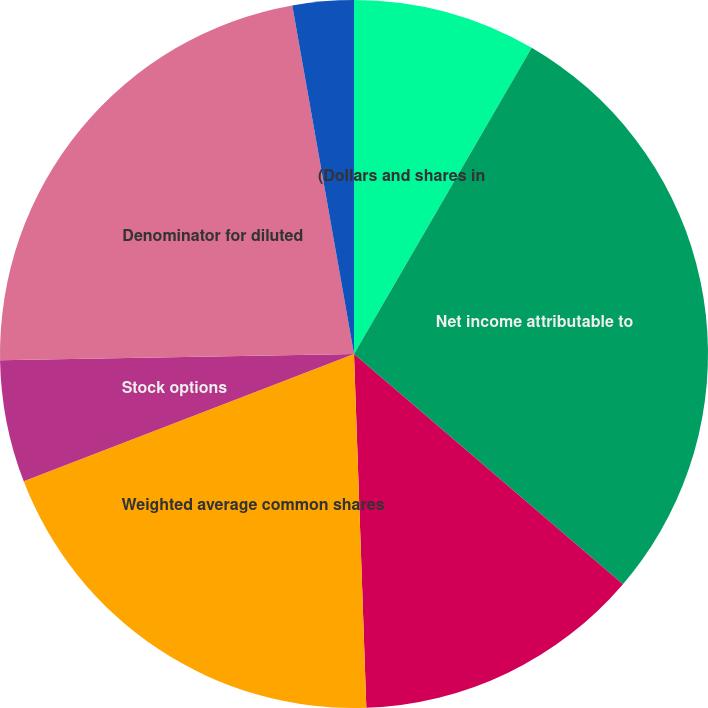<chart> <loc_0><loc_0><loc_500><loc_500><pie_chart><fcel>(Dollars and shares in<fcel>Net income attributable to<fcel>Net income available to common<fcel>Weighted average common shares<fcel>Stock options<fcel>Denominator for diluted<fcel>Basic<fcel>Diluted<nl><fcel>8.37%<fcel>27.9%<fcel>13.18%<fcel>19.7%<fcel>5.58%<fcel>22.49%<fcel>2.79%<fcel>0.0%<nl></chart> 